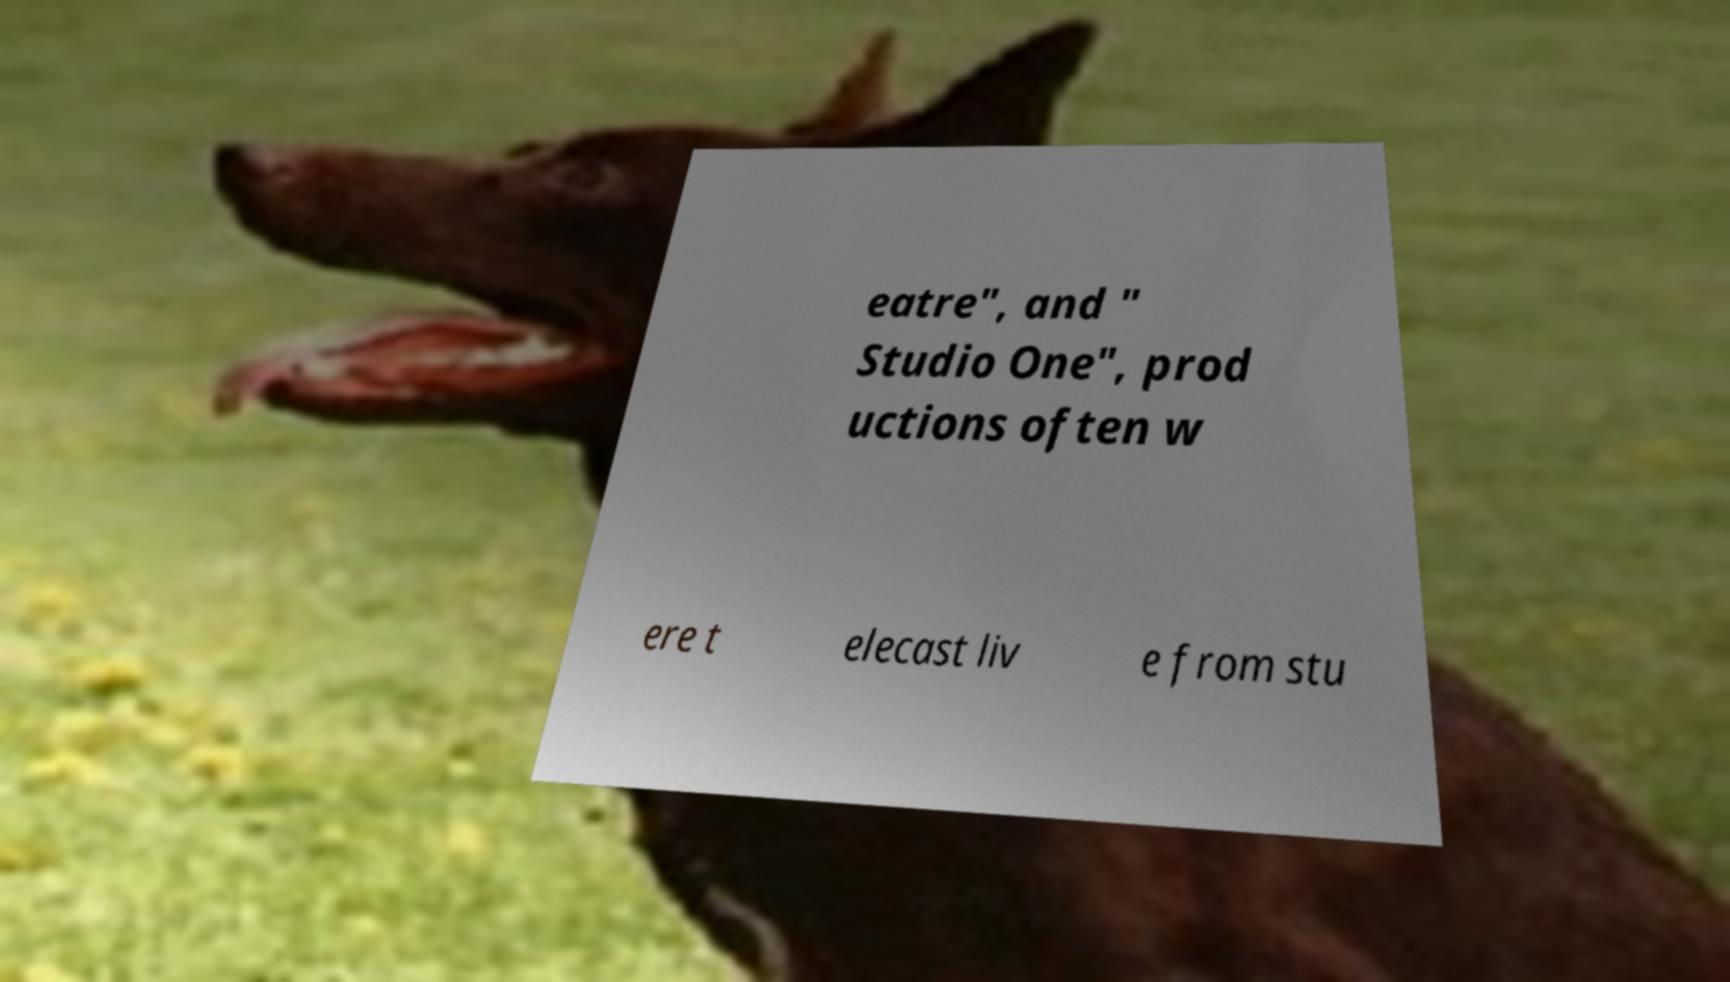What messages or text are displayed in this image? I need them in a readable, typed format. eatre", and " Studio One", prod uctions often w ere t elecast liv e from stu 